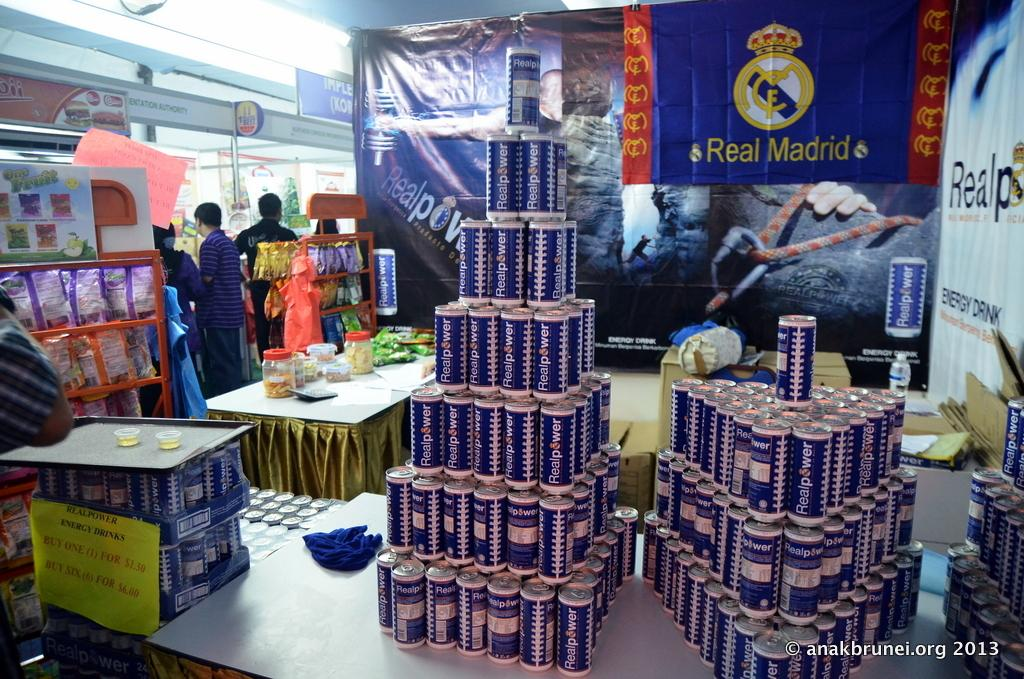What type of establishment is depicted in the image? The image shows the inside view of a supermarket. What type of items can be seen on the shelves in the image? There are tin cans and plastic containers on the racks in the image. What can be inferred about the variety of products available in the supermarket? The presence of different types of products on the racks suggests that the supermarket offers a variety of items for customers to choose from. What type of coil is used to power the ship in the image? There is no ship or coil present in the image; it shows the inside view of a supermarket. What is the mysterious thing hanging from the ceiling in the image? There is no mysterious thing hanging from the ceiling in the image; it shows the inside view of a supermarket with regular store fixtures and products. 